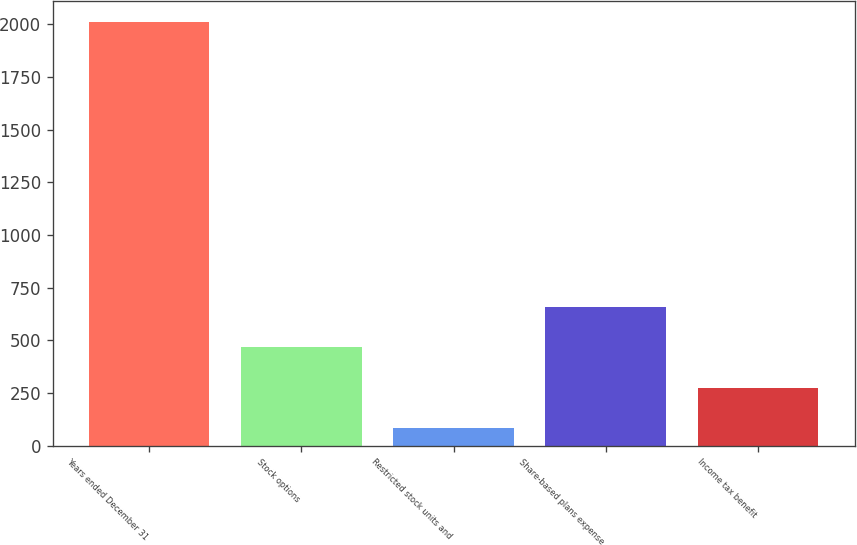Convert chart. <chart><loc_0><loc_0><loc_500><loc_500><bar_chart><fcel>Years ended December 31<fcel>Stock options<fcel>Restricted stock units and<fcel>Share-based plans expense<fcel>Income tax benefit<nl><fcel>2010<fcel>468.4<fcel>83<fcel>661.1<fcel>275.7<nl></chart> 